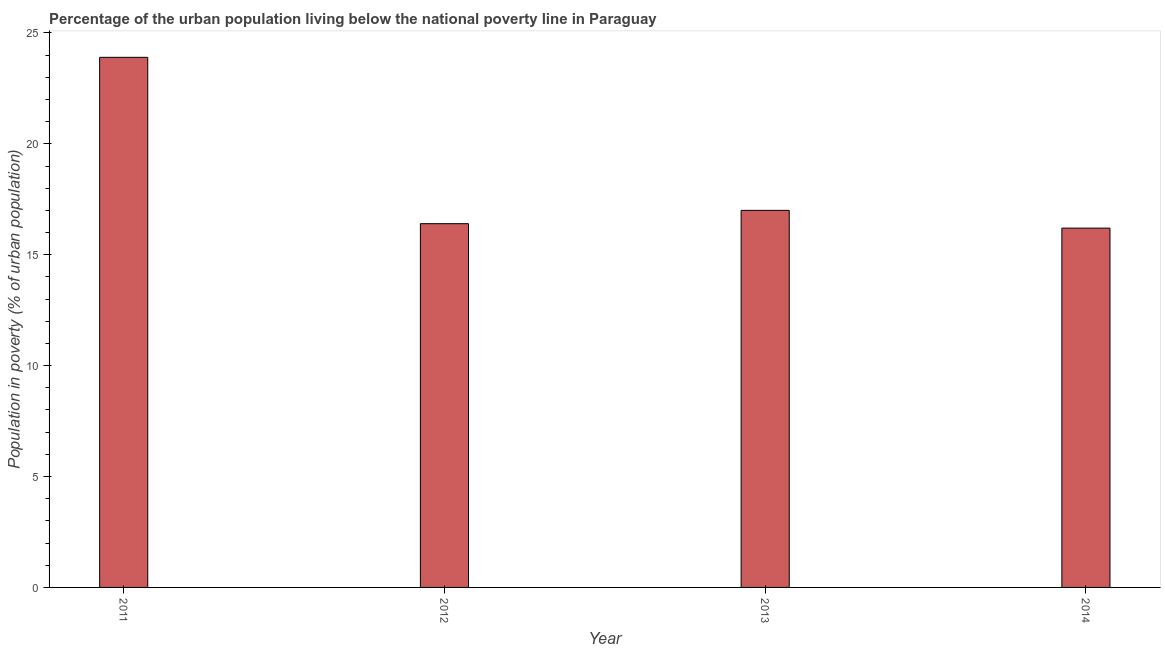What is the title of the graph?
Keep it short and to the point. Percentage of the urban population living below the national poverty line in Paraguay. What is the label or title of the Y-axis?
Make the answer very short. Population in poverty (% of urban population). Across all years, what is the maximum percentage of urban population living below poverty line?
Provide a short and direct response. 23.9. Across all years, what is the minimum percentage of urban population living below poverty line?
Make the answer very short. 16.2. In which year was the percentage of urban population living below poverty line maximum?
Provide a short and direct response. 2011. In which year was the percentage of urban population living below poverty line minimum?
Make the answer very short. 2014. What is the sum of the percentage of urban population living below poverty line?
Ensure brevity in your answer.  73.5. What is the average percentage of urban population living below poverty line per year?
Your answer should be very brief. 18.38. What is the ratio of the percentage of urban population living below poverty line in 2012 to that in 2013?
Give a very brief answer. 0.96. What is the difference between the highest and the lowest percentage of urban population living below poverty line?
Your response must be concise. 7.7. In how many years, is the percentage of urban population living below poverty line greater than the average percentage of urban population living below poverty line taken over all years?
Your answer should be compact. 1. How many bars are there?
Offer a very short reply. 4. Are all the bars in the graph horizontal?
Make the answer very short. No. How many years are there in the graph?
Your answer should be very brief. 4. What is the Population in poverty (% of urban population) of 2011?
Keep it short and to the point. 23.9. What is the Population in poverty (% of urban population) in 2012?
Provide a short and direct response. 16.4. What is the Population in poverty (% of urban population) in 2013?
Your response must be concise. 17. What is the difference between the Population in poverty (% of urban population) in 2011 and 2012?
Ensure brevity in your answer.  7.5. What is the difference between the Population in poverty (% of urban population) in 2011 and 2013?
Provide a succinct answer. 6.9. What is the difference between the Population in poverty (% of urban population) in 2011 and 2014?
Offer a terse response. 7.7. What is the difference between the Population in poverty (% of urban population) in 2012 and 2014?
Your answer should be very brief. 0.2. What is the difference between the Population in poverty (% of urban population) in 2013 and 2014?
Your answer should be compact. 0.8. What is the ratio of the Population in poverty (% of urban population) in 2011 to that in 2012?
Offer a very short reply. 1.46. What is the ratio of the Population in poverty (% of urban population) in 2011 to that in 2013?
Offer a terse response. 1.41. What is the ratio of the Population in poverty (% of urban population) in 2011 to that in 2014?
Make the answer very short. 1.48. What is the ratio of the Population in poverty (% of urban population) in 2012 to that in 2013?
Your answer should be compact. 0.96. What is the ratio of the Population in poverty (% of urban population) in 2012 to that in 2014?
Your response must be concise. 1.01. What is the ratio of the Population in poverty (% of urban population) in 2013 to that in 2014?
Your answer should be compact. 1.05. 